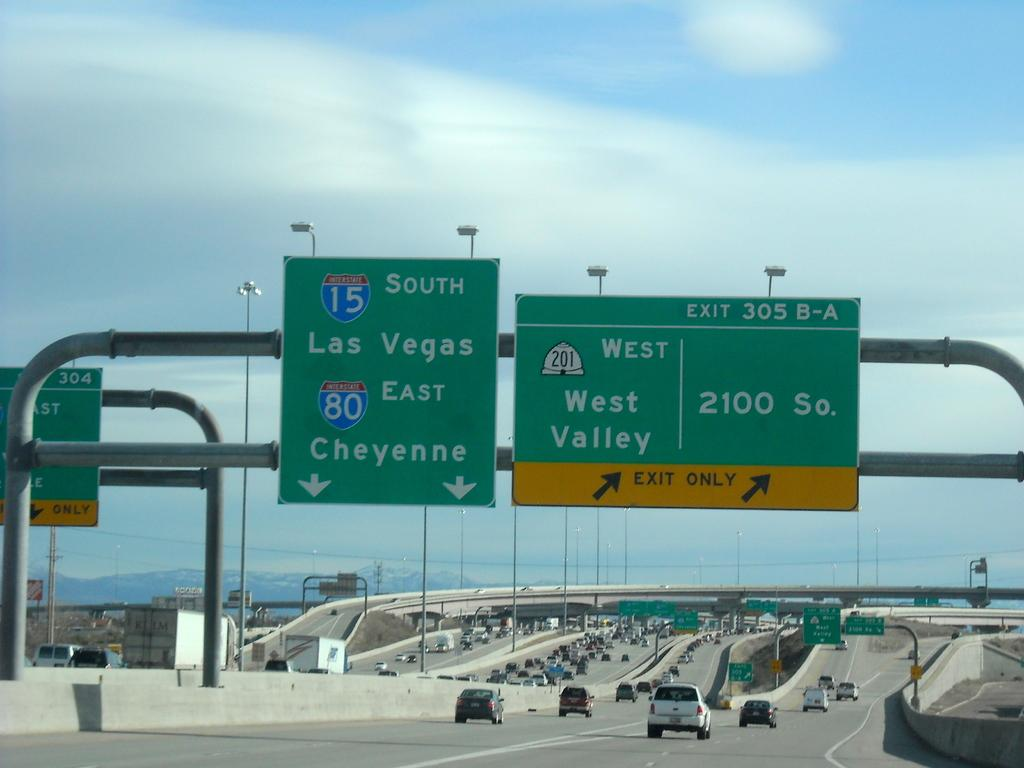<image>
Offer a succinct explanation of the picture presented. Road signs showing that Exits 305 A and B are coming up on the right. 